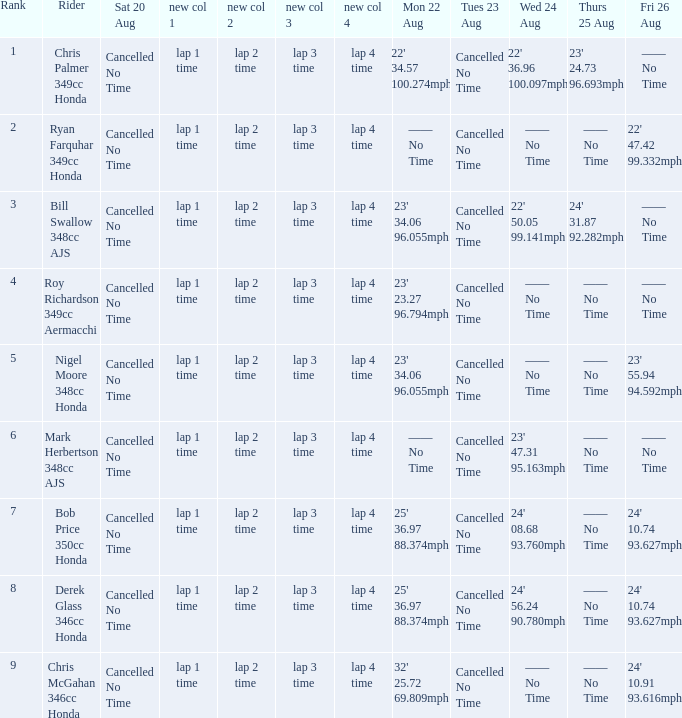I'm looking to parse the entire table for insights. Could you assist me with that? {'header': ['Rank', 'Rider', 'Sat 20 Aug', 'new col 1', 'new col 2', 'new col 3', 'new col 4', 'Mon 22 Aug', 'Tues 23 Aug', 'Wed 24 Aug', 'Thurs 25 Aug', 'Fri 26 Aug'], 'rows': [['1', 'Chris Palmer 349cc Honda', 'Cancelled No Time', 'lap 1 time', 'lap 2 time', 'lap 3 time', 'lap 4 time', "22' 34.57 100.274mph", 'Cancelled No Time', "22' 36.96 100.097mph", "23' 24.73 96.693mph", '—— No Time'], ['2', 'Ryan Farquhar 349cc Honda', 'Cancelled No Time', 'lap 1 time', 'lap 2 time', 'lap 3 time', 'lap 4 time', '—— No Time', 'Cancelled No Time', '—— No Time', '—— No Time', "22' 47.42 99.332mph"], ['3', 'Bill Swallow 348cc AJS', 'Cancelled No Time', 'lap 1 time', 'lap 2 time', 'lap 3 time', 'lap 4 time', "23' 34.06 96.055mph", 'Cancelled No Time', "22' 50.05 99.141mph", "24' 31.87 92.282mph", '—— No Time'], ['4', 'Roy Richardson 349cc Aermacchi', 'Cancelled No Time', 'lap 1 time', 'lap 2 time', 'lap 3 time', 'lap 4 time', "23' 23.27 96.794mph", 'Cancelled No Time', '—— No Time', '—— No Time', '—— No Time'], ['5', 'Nigel Moore 348cc Honda', 'Cancelled No Time', 'lap 1 time', 'lap 2 time', 'lap 3 time', 'lap 4 time', "23' 34.06 96.055mph", 'Cancelled No Time', '—— No Time', '—— No Time', "23' 55.94 94.592mph"], ['6', 'Mark Herbertson 348cc AJS', 'Cancelled No Time', 'lap 1 time', 'lap 2 time', 'lap 3 time', 'lap 4 time', '—— No Time', 'Cancelled No Time', "23' 47.31 95.163mph", '—— No Time', '—— No Time'], ['7', 'Bob Price 350cc Honda', 'Cancelled No Time', 'lap 1 time', 'lap 2 time', 'lap 3 time', 'lap 4 time', "25' 36.97 88.374mph", 'Cancelled No Time', "24' 08.68 93.760mph", '—— No Time', "24' 10.74 93.627mph"], ['8', 'Derek Glass 346cc Honda', 'Cancelled No Time', 'lap 1 time', 'lap 2 time', 'lap 3 time', 'lap 4 time', "25' 36.97 88.374mph", 'Cancelled No Time', "24' 56.24 90.780mph", '—— No Time', "24' 10.74 93.627mph"], ['9', 'Chris McGahan 346cc Honda', 'Cancelled No Time', 'lap 1 time', 'lap 2 time', 'lap 3 time', 'lap 4 time', "32' 25.72 69.809mph", 'Cancelled No Time', '—— No Time', '—— No Time', "24' 10.91 93.616mph"]]} What is every entry for Friday August 26 if the entry for Monday August 22 is 32' 25.72 69.809mph? 24' 10.91 93.616mph. 